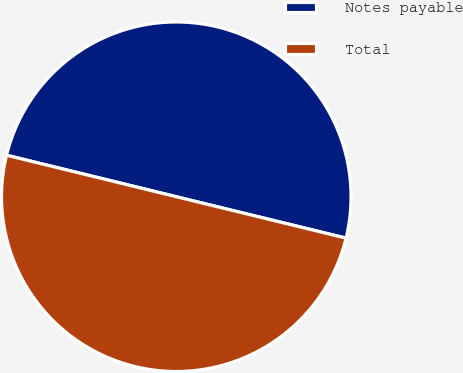Convert chart to OTSL. <chart><loc_0><loc_0><loc_500><loc_500><pie_chart><fcel>Notes payable<fcel>Total<nl><fcel>49.99%<fcel>50.01%<nl></chart> 